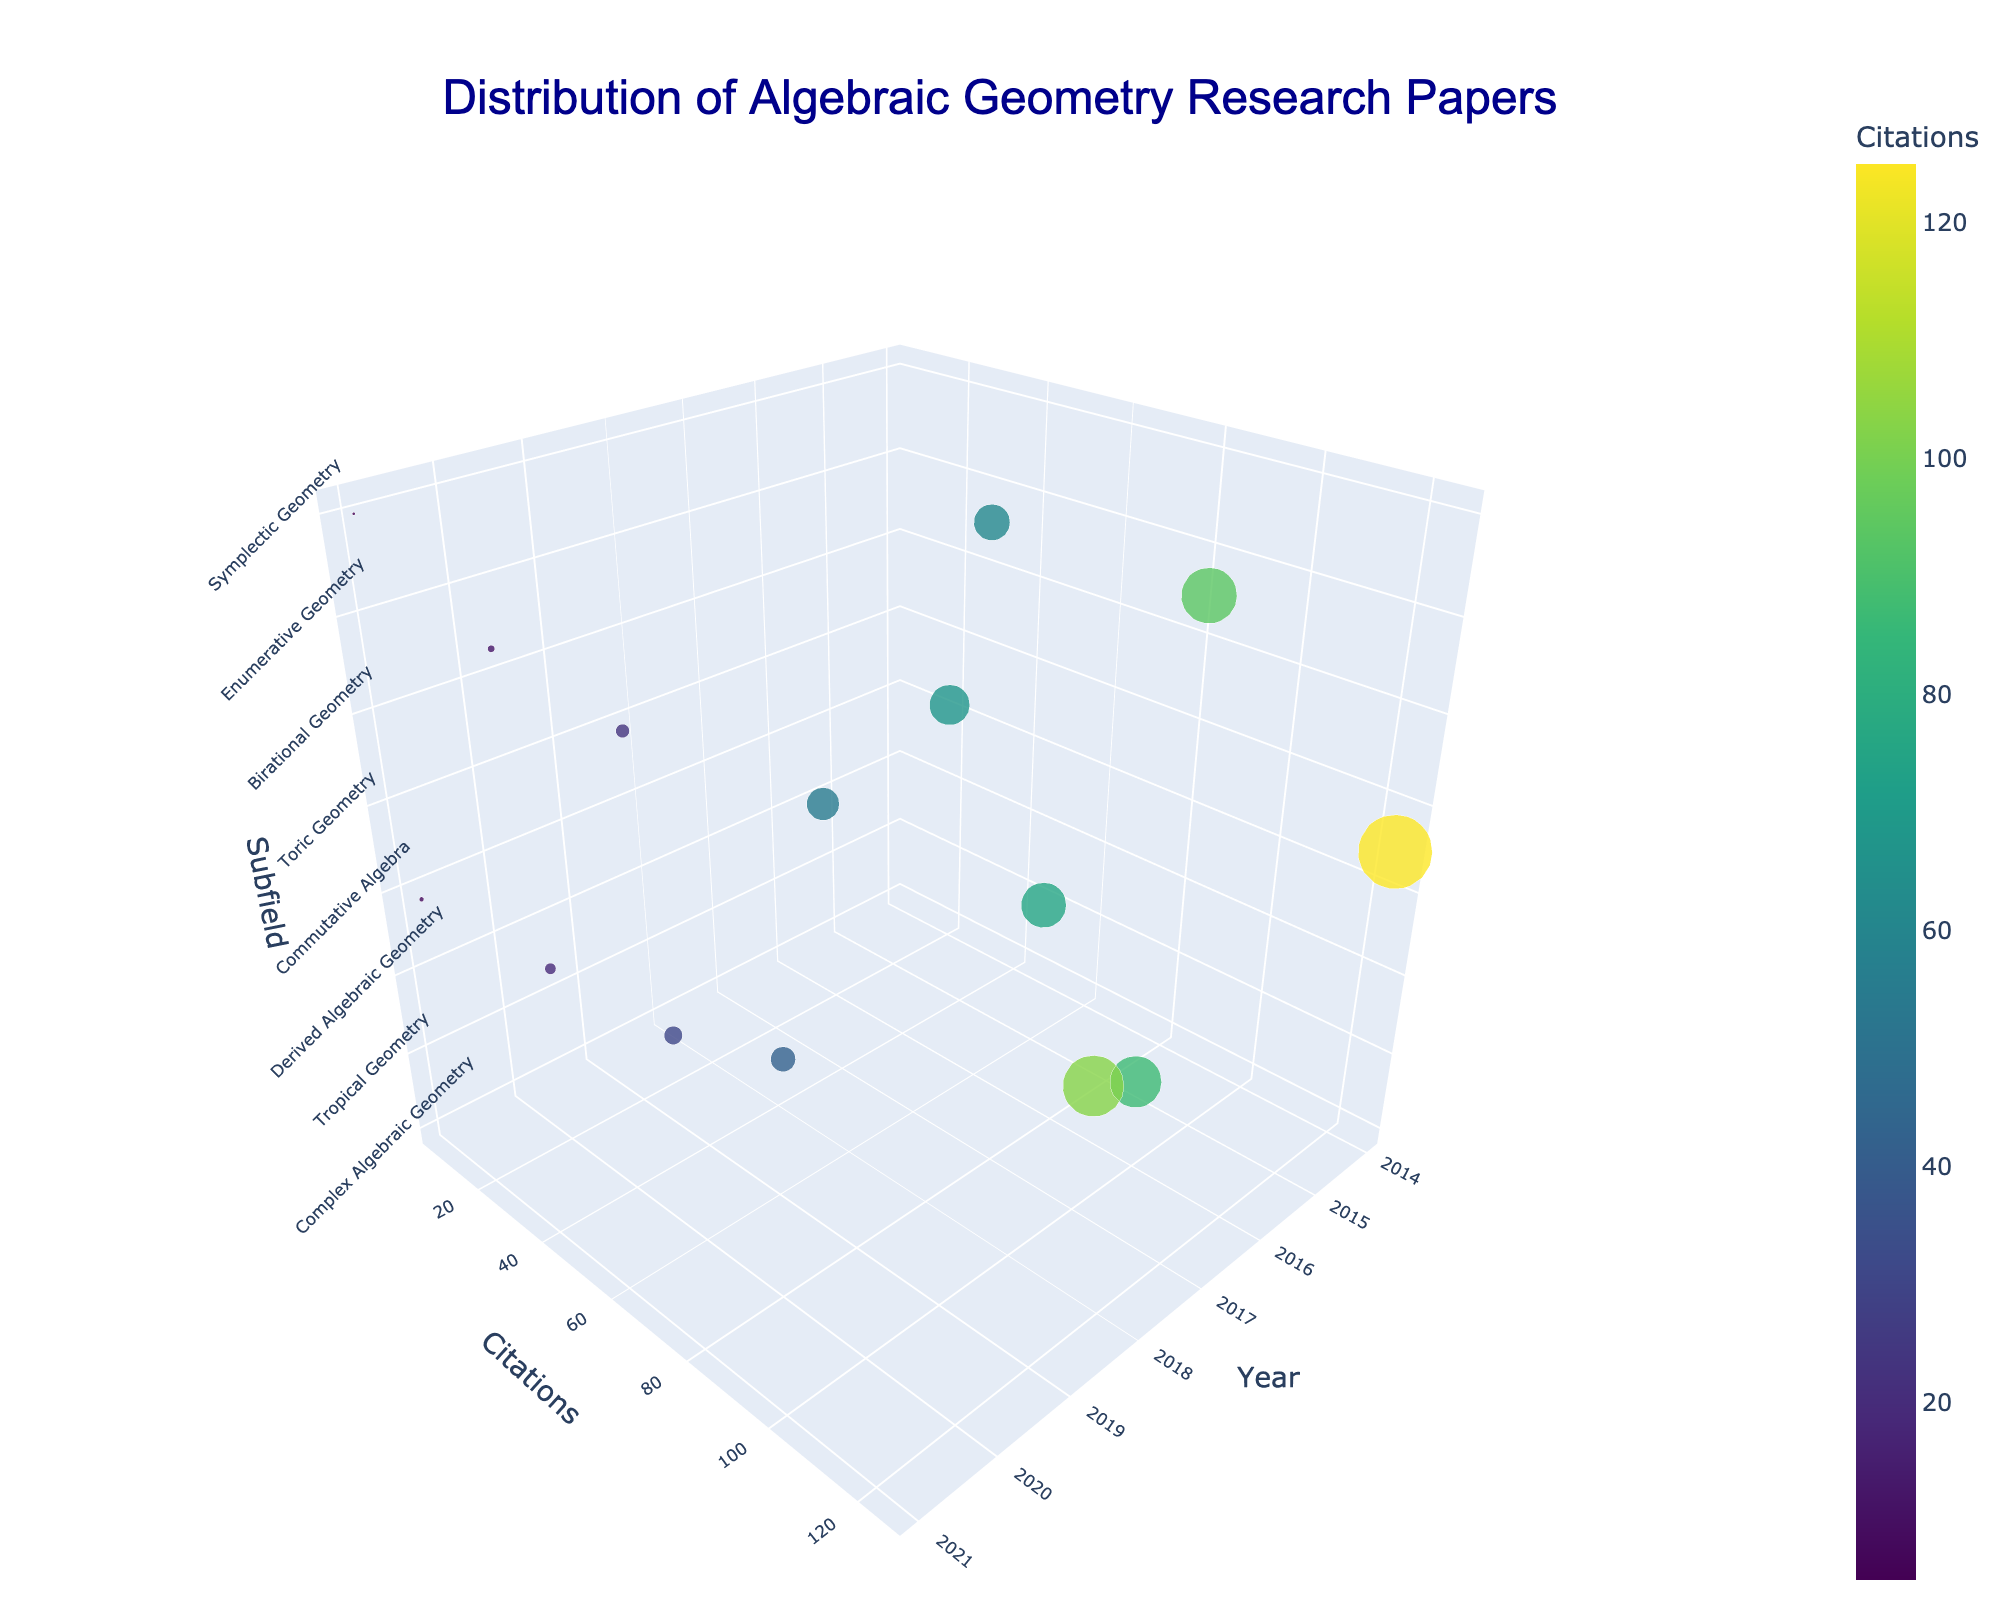what is the title of the figure? The title is typically located at the top of a figure. In this case, it says "Distribution of Algebraic Geometry Research Papers".
Answer: Distribution of Algebraic Geometry Research Papers How many Algebraic Topology papers are there? Check for data points labeled with "Algebraic Topology" in the z-axis (Subfield). There is 1 such point.
Answer: 1 Which year has the highest citation count for a paper? Examine the y-axis (Citations) for the highest point, then cross-reference with the x-axis (Year). The year 2014 has the highest citation count with 125 citations for the "Intersection Homology Theory" paper.
Answer: 2014 What is the most common subfield with more than 50 citations? Identify subfields with more than 50 citations by looking at the y-axis values, then count occurrences of each subfield. The subfields Complex Algebraic Geometry, Computational Algebraic Geometry, and Enumerative Geometry all have more than 50 citations, but appear only once each.
Answer: None Which subfield has the least number of citations? Scan the z-axis (Subfield) and find the point with the minimum y-axis (Citations) value. The subfields Local Cohomology and Its Applications, Floer Homology and Applications, and Quantum Groups and Hopf Algebras have the lowest citation values with 8, 5, and 12 citations, respectively.
Answer: Floer Homology and Applications How does the number of citations in 2018 compare between the two papers? Find the two points in the x-axis (Year) for 2018 and compare their y-axis (Citations). The paper "Rational Points on Elliptic Curves" has 42 citations and the paper "Toric Varieties and Mirror Symmetry" has 55 citations. 42 < 55.
Answer: The paper "Toric Varieties and Mirror Symmetry" has more citations What is the average citation count for papers from 2019? Look at the points in the x-axis (Year) for 2019, sum their y-axis (Citations) and divide by the number of points. There are two papers: "Tropical Intersection Theory" with 31 citations and "Moduli Spaces of Vector Bundles" with 23 citations. (31 + 23) / 2 = 27.
Answer: 27 Which subfield has the largest marker size at year 2017? Examine the marker sizes at the year 2017, which correspond to citations. The largest marker belongs to "Groebner Bases and Applications" in the Computational Algebraic Geometry subfield with 103 citations.
Answer: Computational Algebraic Geometry How many papers have less than 30 citations? Count the number of points with y-axis values less than 30. The papers "Derived Categories of Coherent Sheaves" (19), "Local Cohomology and Its Applications" (8), "Moduli Spaces of Vector Bundles" (23), "Quantum Groups and Hopf Algebras" (12), and "Floer Homology and Applications" (5).
Answer: 5 